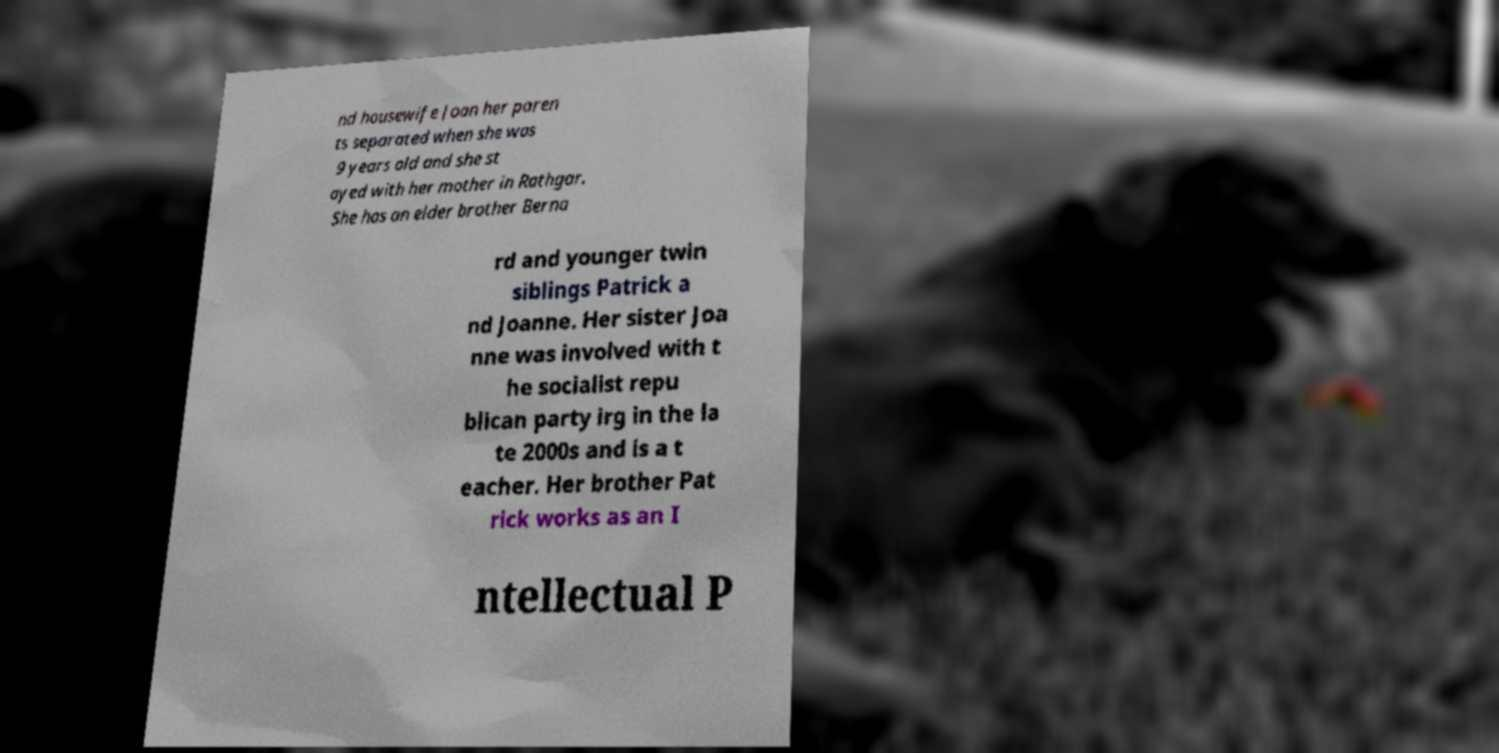Could you extract and type out the text from this image? nd housewife Joan her paren ts separated when she was 9 years old and she st ayed with her mother in Rathgar. She has an elder brother Berna rd and younger twin siblings Patrick a nd Joanne. Her sister Joa nne was involved with t he socialist repu blican party irg in the la te 2000s and is a t eacher. Her brother Pat rick works as an I ntellectual P 